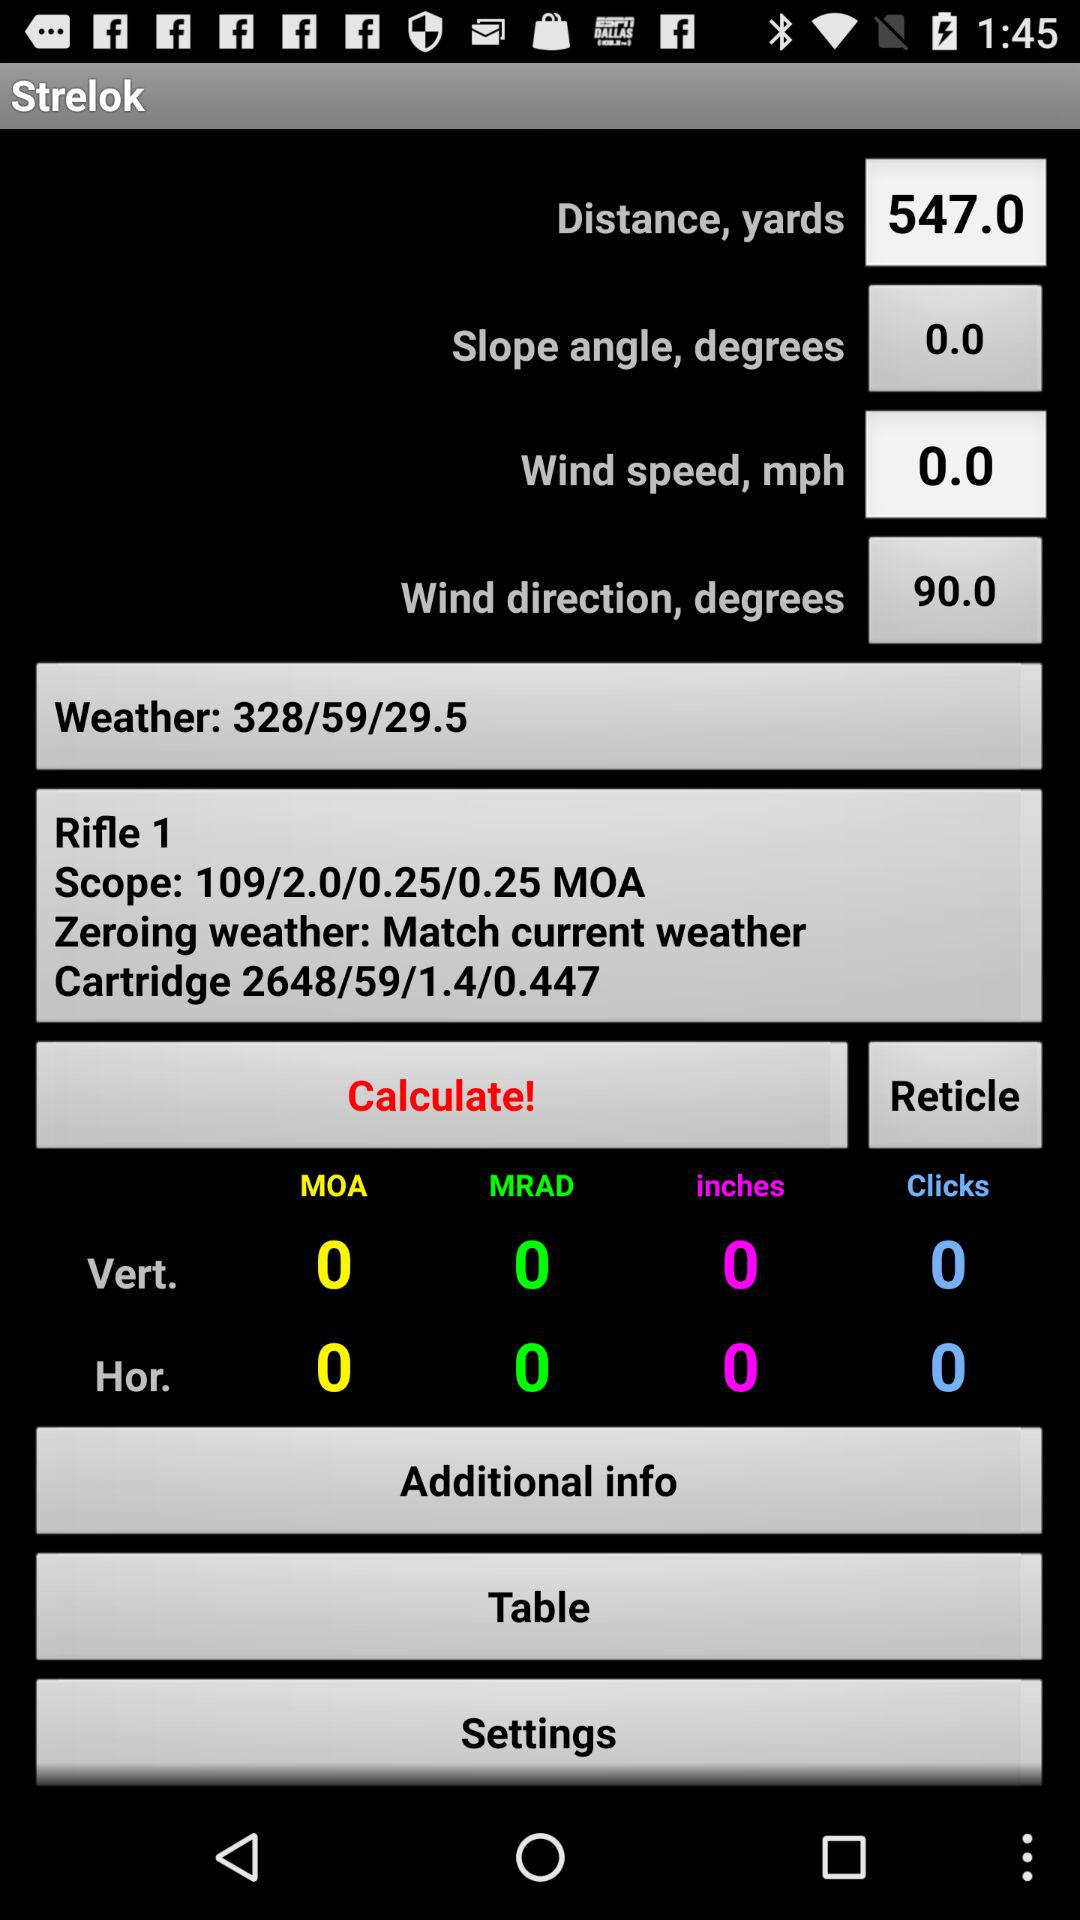What is the wind speed? The wind speed is 0 mph. 